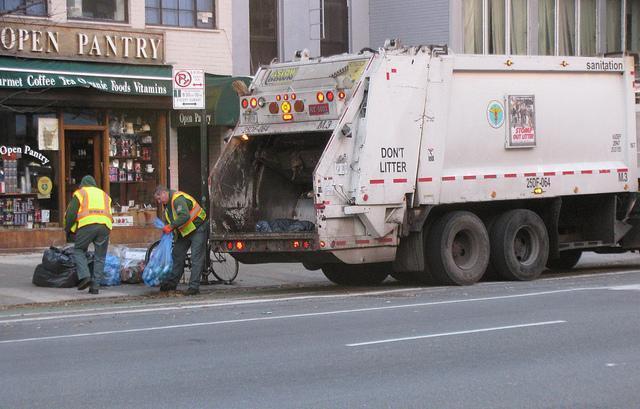How many people are in the photo?
Give a very brief answer. 2. 